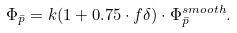<formula> <loc_0><loc_0><loc_500><loc_500>\Phi _ { \bar { p } } = k ( 1 + 0 . 7 5 \cdot f \delta ) \cdot \Phi _ { \bar { p } } ^ { s m o o t h } .</formula> 